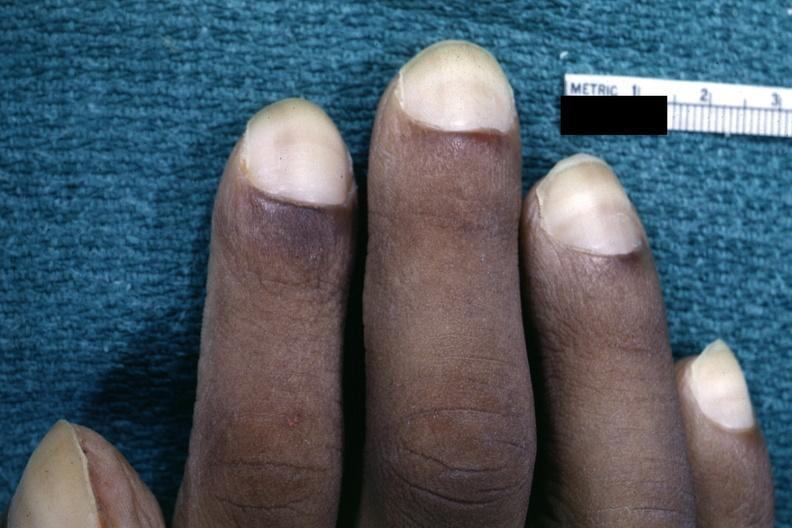s hematoma present?
Answer the question using a single word or phrase. No 